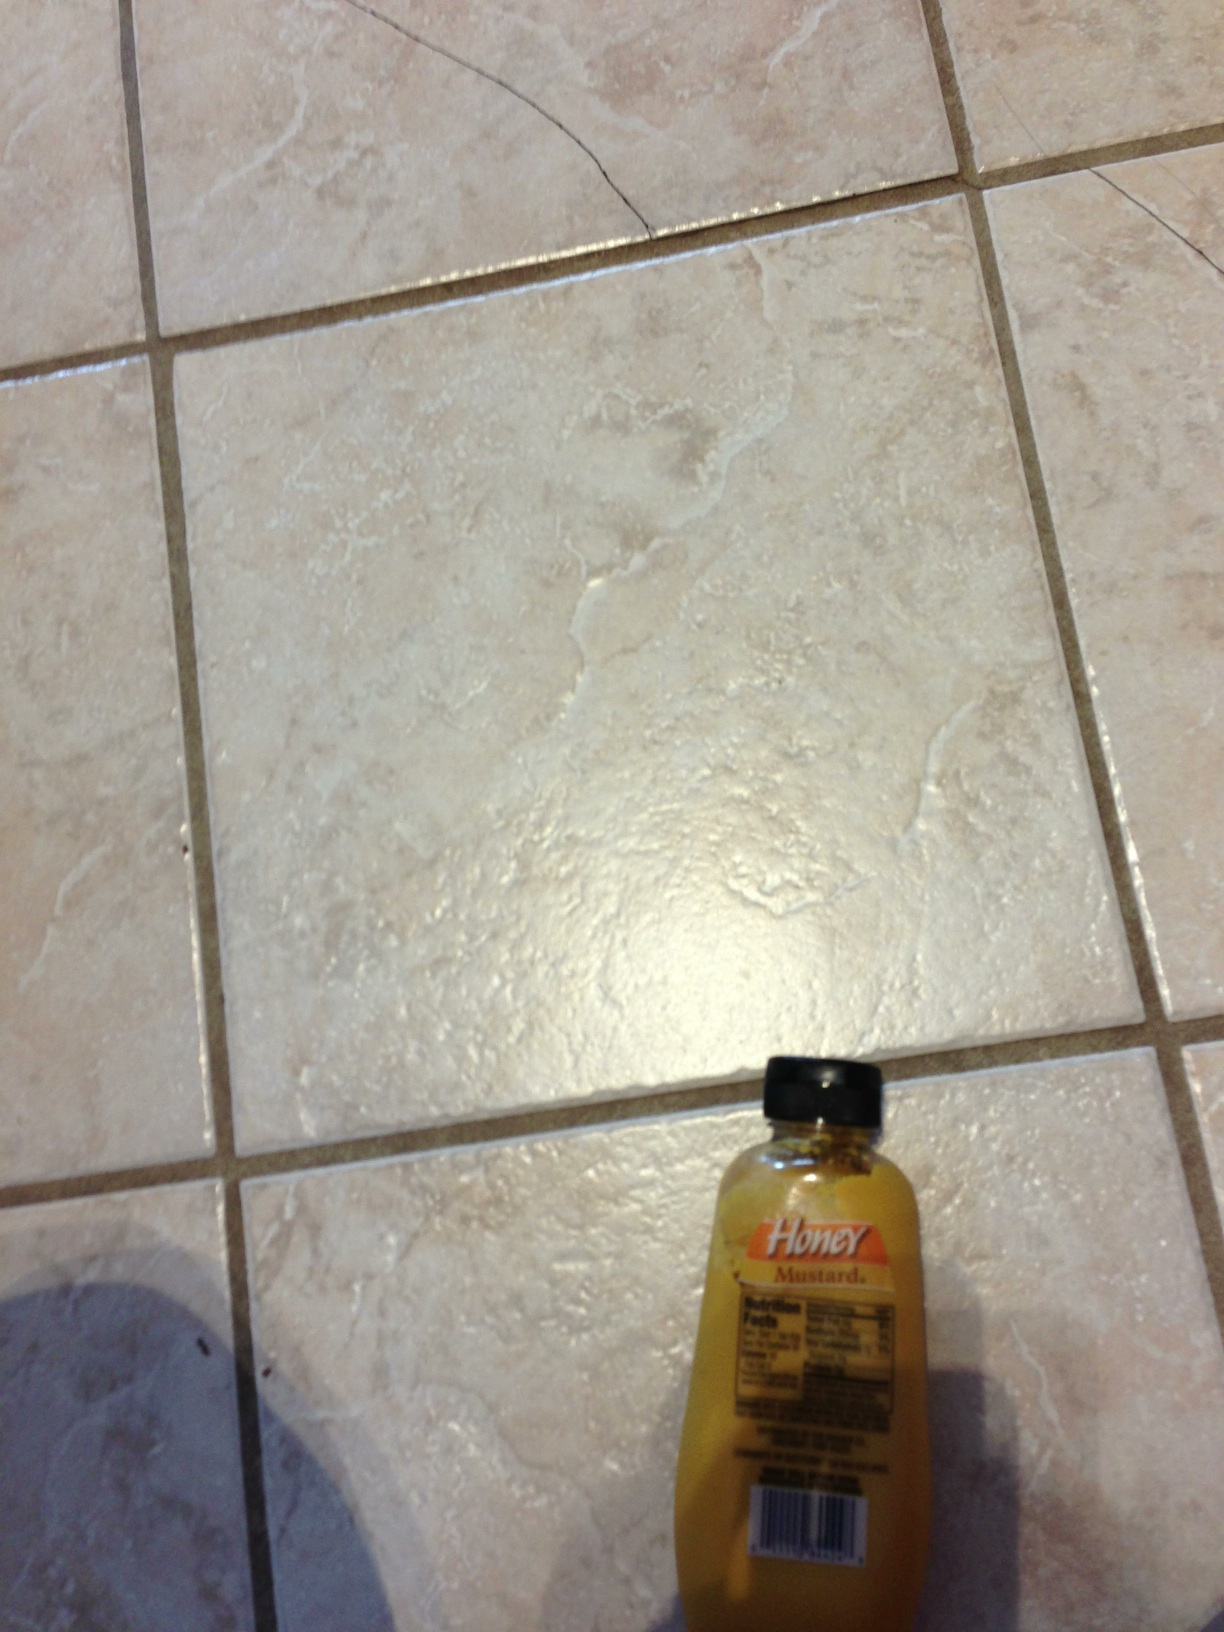Describe a realistic scenario involving honey mustard in a household setting. In a busy household, honey mustard is often a go-to condiment for quick and easy meals. On a typical weeknight, a parent uses it to prepare a simple yet delicious dinner by glazing chicken breasts before baking. The resulting dish is served with a side of steamed vegetables, making a nutritious and flavorful meal that the whole family enjoys. 